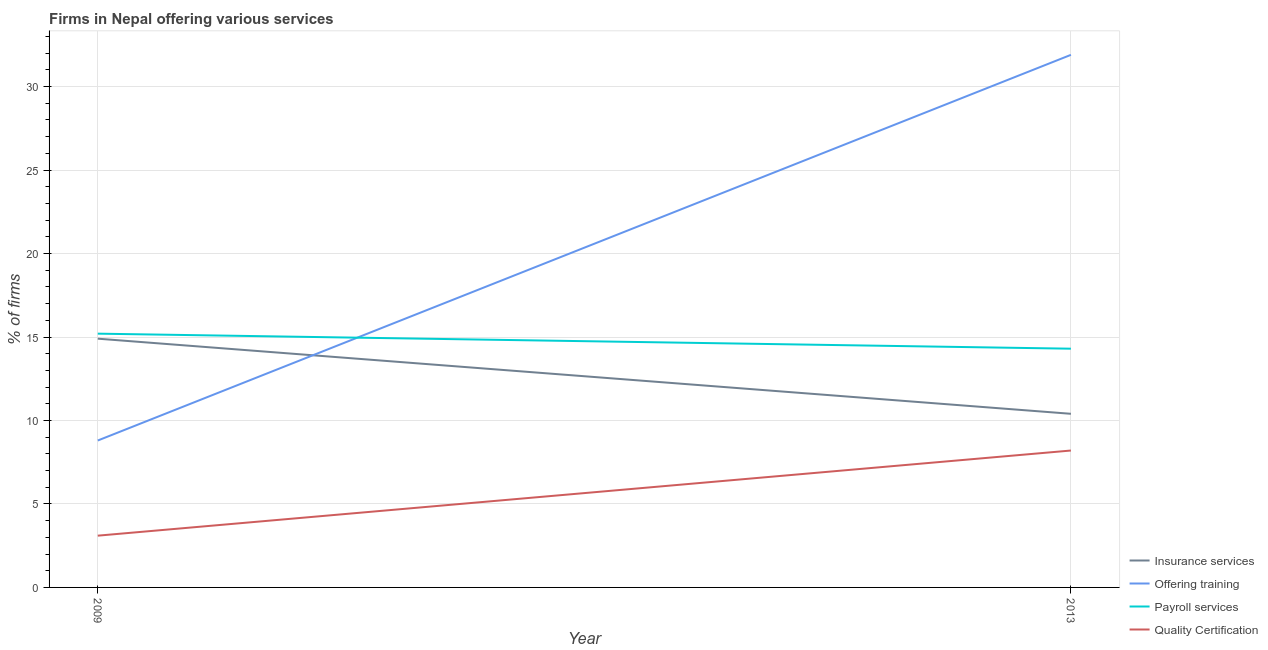Does the line corresponding to percentage of firms offering payroll services intersect with the line corresponding to percentage of firms offering quality certification?
Provide a succinct answer. No. What is the percentage of firms offering payroll services in 2009?
Offer a very short reply. 15.2. Across all years, what is the minimum percentage of firms offering payroll services?
Make the answer very short. 14.3. In which year was the percentage of firms offering quality certification maximum?
Your answer should be compact. 2013. What is the total percentage of firms offering training in the graph?
Provide a succinct answer. 40.7. What is the difference between the percentage of firms offering payroll services in 2009 and that in 2013?
Your answer should be very brief. 0.9. What is the difference between the percentage of firms offering payroll services in 2009 and the percentage of firms offering insurance services in 2013?
Make the answer very short. 4.8. What is the average percentage of firms offering payroll services per year?
Ensure brevity in your answer.  14.75. In the year 2013, what is the difference between the percentage of firms offering insurance services and percentage of firms offering payroll services?
Your answer should be compact. -3.9. What is the ratio of the percentage of firms offering quality certification in 2009 to that in 2013?
Your answer should be compact. 0.38. Is the percentage of firms offering insurance services in 2009 less than that in 2013?
Keep it short and to the point. No. In how many years, is the percentage of firms offering payroll services greater than the average percentage of firms offering payroll services taken over all years?
Provide a succinct answer. 1. Is it the case that in every year, the sum of the percentage of firms offering insurance services and percentage of firms offering training is greater than the percentage of firms offering payroll services?
Offer a terse response. Yes. Does the percentage of firms offering quality certification monotonically increase over the years?
Ensure brevity in your answer.  Yes. Is the percentage of firms offering training strictly greater than the percentage of firms offering payroll services over the years?
Your response must be concise. No. Is the percentage of firms offering quality certification strictly less than the percentage of firms offering payroll services over the years?
Your response must be concise. Yes. How many lines are there?
Your answer should be compact. 4. How many years are there in the graph?
Your answer should be compact. 2. Are the values on the major ticks of Y-axis written in scientific E-notation?
Ensure brevity in your answer.  No. Does the graph contain grids?
Give a very brief answer. Yes. How are the legend labels stacked?
Offer a very short reply. Vertical. What is the title of the graph?
Make the answer very short. Firms in Nepal offering various services . Does "Social Insurance" appear as one of the legend labels in the graph?
Offer a terse response. No. What is the label or title of the X-axis?
Make the answer very short. Year. What is the label or title of the Y-axis?
Ensure brevity in your answer.  % of firms. What is the % of firms of Insurance services in 2009?
Make the answer very short. 14.9. What is the % of firms of Offering training in 2009?
Offer a terse response. 8.8. What is the % of firms in Insurance services in 2013?
Provide a succinct answer. 10.4. What is the % of firms of Offering training in 2013?
Your answer should be very brief. 31.9. What is the % of firms in Quality Certification in 2013?
Provide a short and direct response. 8.2. Across all years, what is the maximum % of firms of Offering training?
Your answer should be very brief. 31.9. Across all years, what is the maximum % of firms in Payroll services?
Provide a succinct answer. 15.2. Across all years, what is the maximum % of firms of Quality Certification?
Provide a succinct answer. 8.2. Across all years, what is the minimum % of firms of Insurance services?
Keep it short and to the point. 10.4. Across all years, what is the minimum % of firms of Offering training?
Ensure brevity in your answer.  8.8. Across all years, what is the minimum % of firms in Payroll services?
Offer a very short reply. 14.3. Across all years, what is the minimum % of firms in Quality Certification?
Your response must be concise. 3.1. What is the total % of firms in Insurance services in the graph?
Your response must be concise. 25.3. What is the total % of firms of Offering training in the graph?
Your answer should be compact. 40.7. What is the total % of firms in Payroll services in the graph?
Your response must be concise. 29.5. What is the total % of firms in Quality Certification in the graph?
Keep it short and to the point. 11.3. What is the difference between the % of firms in Insurance services in 2009 and that in 2013?
Provide a short and direct response. 4.5. What is the difference between the % of firms in Offering training in 2009 and that in 2013?
Keep it short and to the point. -23.1. What is the difference between the % of firms of Quality Certification in 2009 and that in 2013?
Keep it short and to the point. -5.1. What is the difference between the % of firms in Insurance services in 2009 and the % of firms in Payroll services in 2013?
Your answer should be compact. 0.6. What is the difference between the % of firms of Insurance services in 2009 and the % of firms of Quality Certification in 2013?
Provide a short and direct response. 6.7. What is the difference between the % of firms of Payroll services in 2009 and the % of firms of Quality Certification in 2013?
Keep it short and to the point. 7. What is the average % of firms in Insurance services per year?
Make the answer very short. 12.65. What is the average % of firms in Offering training per year?
Keep it short and to the point. 20.35. What is the average % of firms in Payroll services per year?
Ensure brevity in your answer.  14.75. What is the average % of firms in Quality Certification per year?
Offer a terse response. 5.65. In the year 2009, what is the difference between the % of firms of Insurance services and % of firms of Offering training?
Your response must be concise. 6.1. In the year 2009, what is the difference between the % of firms in Offering training and % of firms in Payroll services?
Your answer should be compact. -6.4. In the year 2009, what is the difference between the % of firms of Offering training and % of firms of Quality Certification?
Your answer should be compact. 5.7. In the year 2013, what is the difference between the % of firms in Insurance services and % of firms in Offering training?
Provide a succinct answer. -21.5. In the year 2013, what is the difference between the % of firms in Insurance services and % of firms in Payroll services?
Your answer should be very brief. -3.9. In the year 2013, what is the difference between the % of firms of Offering training and % of firms of Payroll services?
Ensure brevity in your answer.  17.6. In the year 2013, what is the difference between the % of firms of Offering training and % of firms of Quality Certification?
Your answer should be very brief. 23.7. In the year 2013, what is the difference between the % of firms of Payroll services and % of firms of Quality Certification?
Provide a short and direct response. 6.1. What is the ratio of the % of firms of Insurance services in 2009 to that in 2013?
Provide a short and direct response. 1.43. What is the ratio of the % of firms in Offering training in 2009 to that in 2013?
Your answer should be compact. 0.28. What is the ratio of the % of firms of Payroll services in 2009 to that in 2013?
Ensure brevity in your answer.  1.06. What is the ratio of the % of firms in Quality Certification in 2009 to that in 2013?
Offer a very short reply. 0.38. What is the difference between the highest and the second highest % of firms in Offering training?
Ensure brevity in your answer.  23.1. What is the difference between the highest and the second highest % of firms of Payroll services?
Provide a short and direct response. 0.9. What is the difference between the highest and the lowest % of firms of Offering training?
Offer a very short reply. 23.1. What is the difference between the highest and the lowest % of firms of Payroll services?
Provide a succinct answer. 0.9. What is the difference between the highest and the lowest % of firms of Quality Certification?
Provide a short and direct response. 5.1. 